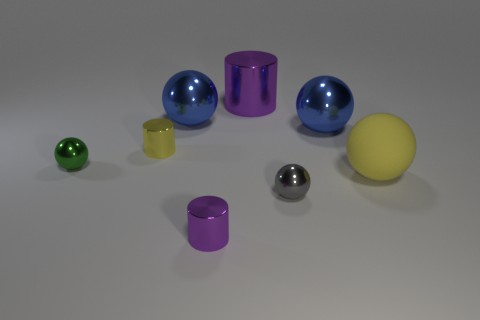Subtract all green spheres. How many spheres are left? 4 Add 2 matte things. How many objects exist? 10 Subtract all yellow balls. How many balls are left? 4 Subtract 2 cylinders. How many cylinders are left? 1 Subtract all big blue shiny objects. Subtract all big matte spheres. How many objects are left? 5 Add 6 tiny shiny cylinders. How many tiny shiny cylinders are left? 8 Add 5 blue metallic things. How many blue metallic things exist? 7 Subtract 0 brown spheres. How many objects are left? 8 Subtract all cylinders. How many objects are left? 5 Subtract all blue cylinders. Subtract all purple spheres. How many cylinders are left? 3 